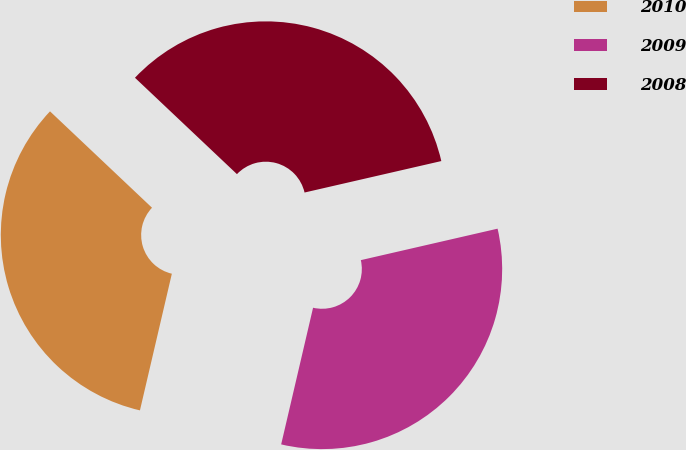Convert chart to OTSL. <chart><loc_0><loc_0><loc_500><loc_500><pie_chart><fcel>2010<fcel>2009<fcel>2008<nl><fcel>33.4%<fcel>32.25%<fcel>34.35%<nl></chart> 